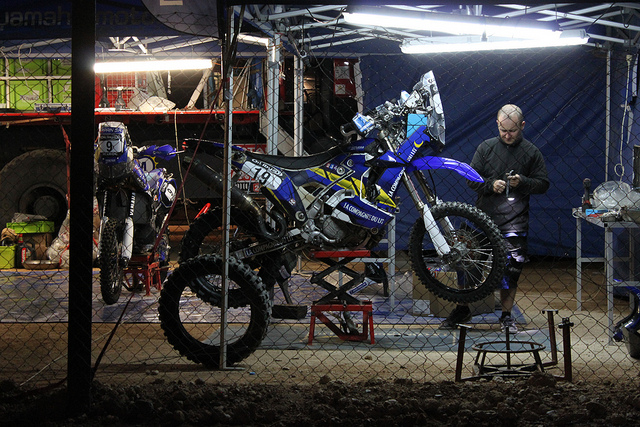Read all the text in this image. 19 U 9 